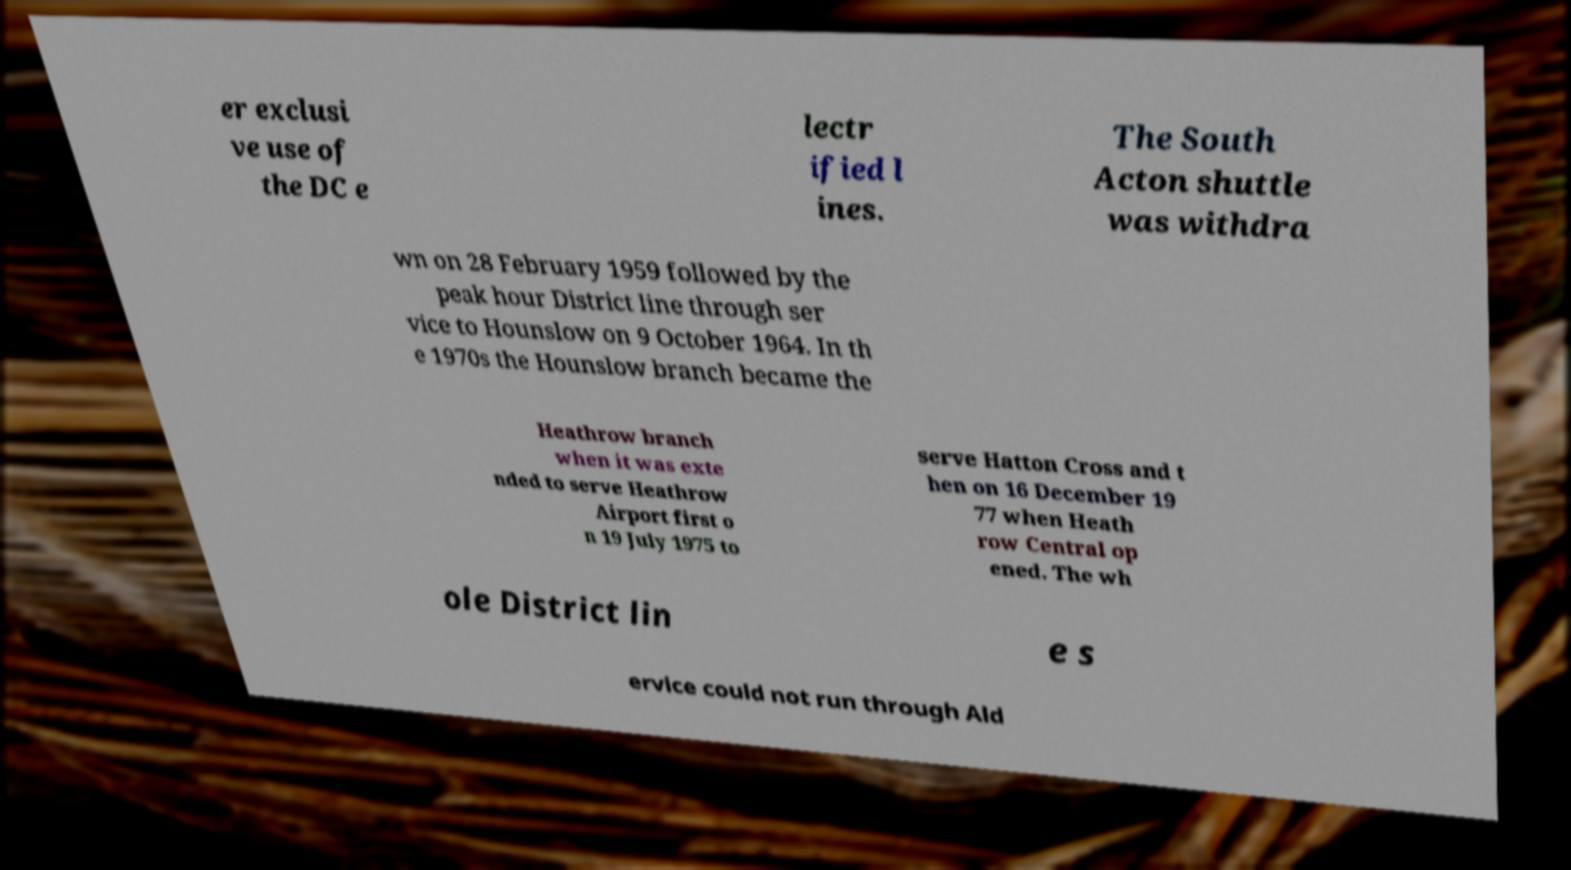For documentation purposes, I need the text within this image transcribed. Could you provide that? er exclusi ve use of the DC e lectr ified l ines. The South Acton shuttle was withdra wn on 28 February 1959 followed by the peak hour District line through ser vice to Hounslow on 9 October 1964. In th e 1970s the Hounslow branch became the Heathrow branch when it was exte nded to serve Heathrow Airport first o n 19 July 1975 to serve Hatton Cross and t hen on 16 December 19 77 when Heath row Central op ened. The wh ole District lin e s ervice could not run through Ald 